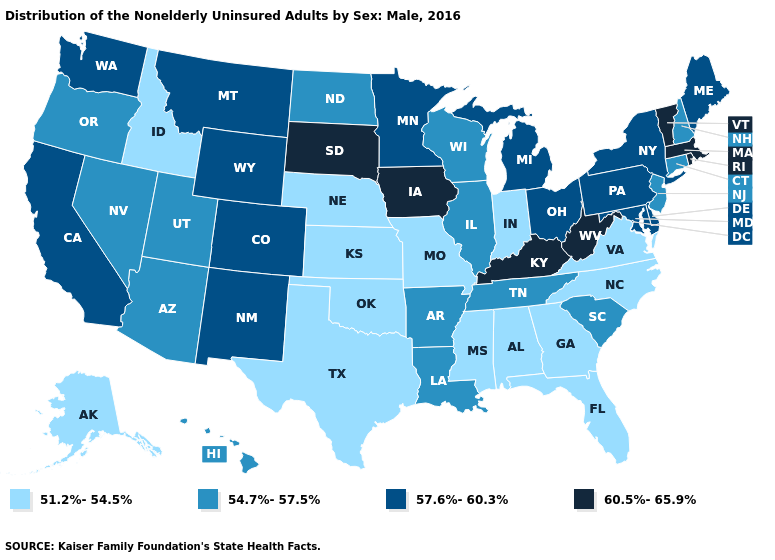What is the lowest value in the USA?
Write a very short answer. 51.2%-54.5%. What is the value of South Dakota?
Write a very short answer. 60.5%-65.9%. What is the value of Texas?
Keep it brief. 51.2%-54.5%. Name the states that have a value in the range 60.5%-65.9%?
Keep it brief. Iowa, Kentucky, Massachusetts, Rhode Island, South Dakota, Vermont, West Virginia. Name the states that have a value in the range 60.5%-65.9%?
Short answer required. Iowa, Kentucky, Massachusetts, Rhode Island, South Dakota, Vermont, West Virginia. What is the highest value in the USA?
Quick response, please. 60.5%-65.9%. What is the value of New Jersey?
Write a very short answer. 54.7%-57.5%. What is the value of Washington?
Answer briefly. 57.6%-60.3%. What is the value of Oregon?
Give a very brief answer. 54.7%-57.5%. Among the states that border New Hampshire , which have the highest value?
Be succinct. Massachusetts, Vermont. Name the states that have a value in the range 60.5%-65.9%?
Be succinct. Iowa, Kentucky, Massachusetts, Rhode Island, South Dakota, Vermont, West Virginia. What is the value of Kentucky?
Keep it brief. 60.5%-65.9%. Among the states that border Montana , which have the lowest value?
Be succinct. Idaho. What is the value of Nebraska?
Give a very brief answer. 51.2%-54.5%. What is the highest value in the MidWest ?
Write a very short answer. 60.5%-65.9%. 